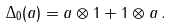<formula> <loc_0><loc_0><loc_500><loc_500>\Delta _ { 0 } ( a ) = a \otimes 1 + 1 \otimes a \, .</formula> 